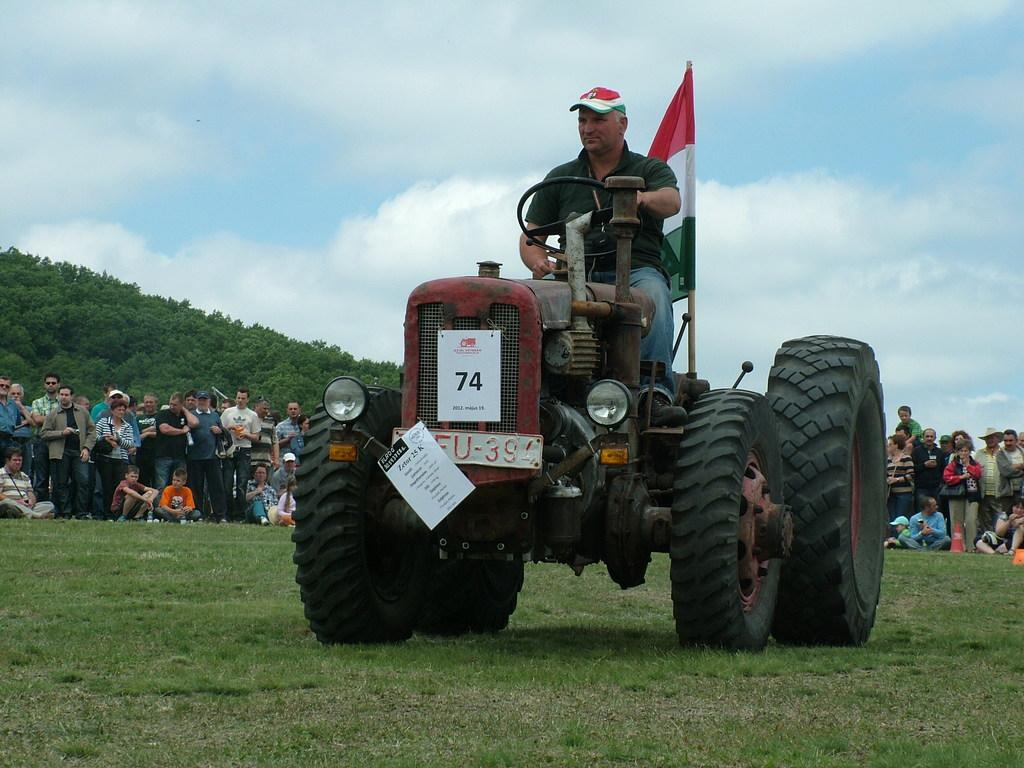What is the person in the image doing? The person in the image is driving a vehicle. What can be seen besides the vehicle in the image? There is a flag, grass, trees, and other people visible in the image. What type of environment is depicted in the image? The image shows a natural environment with grass and trees. How many people are present in the image? There are at least two people in the image, the driver and another person. What type of education is being taught in the image? There is no indication of any educational activity in the image. What is the copper content of the vehicle in the image? There is no information about the composition of the vehicle in the image. 